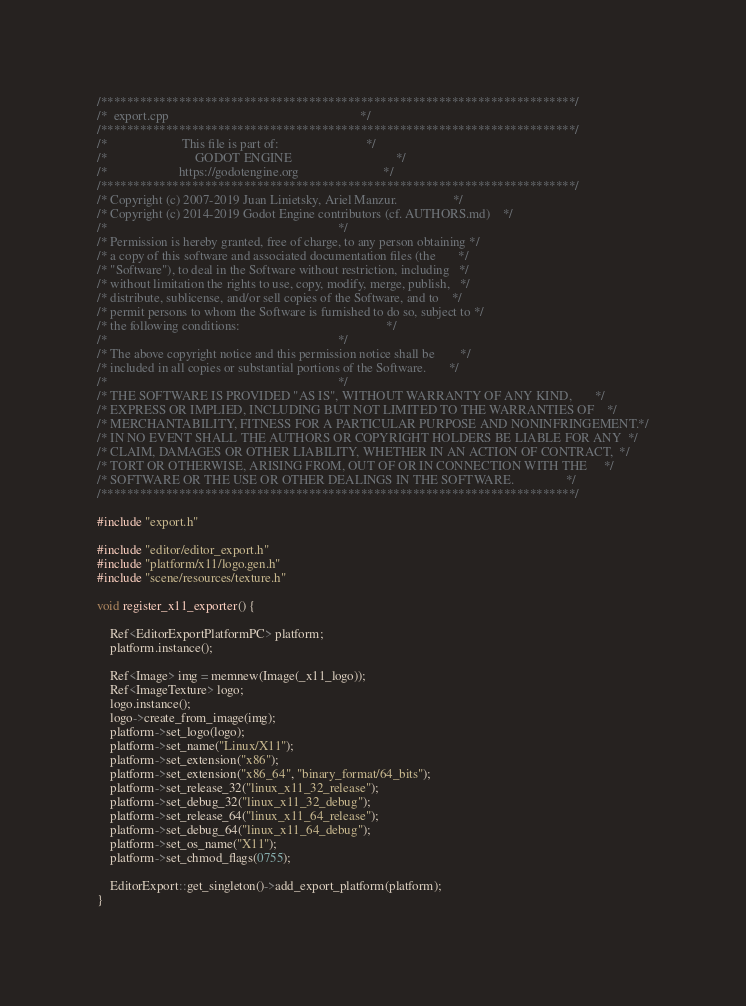Convert code to text. <code><loc_0><loc_0><loc_500><loc_500><_C++_>/*************************************************************************/
/*  export.cpp                                                           */
/*************************************************************************/
/*                       This file is part of:                           */
/*                           GODOT ENGINE                                */
/*                      https://godotengine.org                          */
/*************************************************************************/
/* Copyright (c) 2007-2019 Juan Linietsky, Ariel Manzur.                 */
/* Copyright (c) 2014-2019 Godot Engine contributors (cf. AUTHORS.md)    */
/*                                                                       */
/* Permission is hereby granted, free of charge, to any person obtaining */
/* a copy of this software and associated documentation files (the       */
/* "Software"), to deal in the Software without restriction, including   */
/* without limitation the rights to use, copy, modify, merge, publish,   */
/* distribute, sublicense, and/or sell copies of the Software, and to    */
/* permit persons to whom the Software is furnished to do so, subject to */
/* the following conditions:                                             */
/*                                                                       */
/* The above copyright notice and this permission notice shall be        */
/* included in all copies or substantial portions of the Software.       */
/*                                                                       */
/* THE SOFTWARE IS PROVIDED "AS IS", WITHOUT WARRANTY OF ANY KIND,       */
/* EXPRESS OR IMPLIED, INCLUDING BUT NOT LIMITED TO THE WARRANTIES OF    */
/* MERCHANTABILITY, FITNESS FOR A PARTICULAR PURPOSE AND NONINFRINGEMENT.*/
/* IN NO EVENT SHALL THE AUTHORS OR COPYRIGHT HOLDERS BE LIABLE FOR ANY  */
/* CLAIM, DAMAGES OR OTHER LIABILITY, WHETHER IN AN ACTION OF CONTRACT,  */
/* TORT OR OTHERWISE, ARISING FROM, OUT OF OR IN CONNECTION WITH THE     */
/* SOFTWARE OR THE USE OR OTHER DEALINGS IN THE SOFTWARE.                */
/*************************************************************************/

#include "export.h"

#include "editor/editor_export.h"
#include "platform/x11/logo.gen.h"
#include "scene/resources/texture.h"

void register_x11_exporter() {

	Ref<EditorExportPlatformPC> platform;
	platform.instance();

	Ref<Image> img = memnew(Image(_x11_logo));
	Ref<ImageTexture> logo;
	logo.instance();
	logo->create_from_image(img);
	platform->set_logo(logo);
	platform->set_name("Linux/X11");
	platform->set_extension("x86");
	platform->set_extension("x86_64", "binary_format/64_bits");
	platform->set_release_32("linux_x11_32_release");
	platform->set_debug_32("linux_x11_32_debug");
	platform->set_release_64("linux_x11_64_release");
	platform->set_debug_64("linux_x11_64_debug");
	platform->set_os_name("X11");
	platform->set_chmod_flags(0755);

	EditorExport::get_singleton()->add_export_platform(platform);
}
</code> 